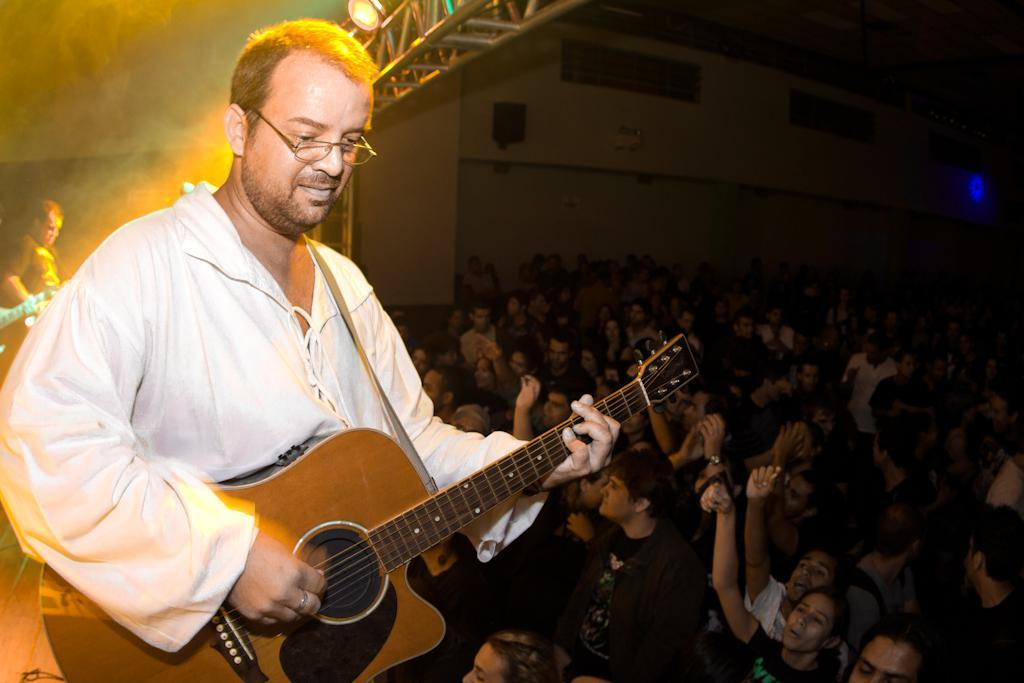What is the man in the image holding? The man is holding a guitar. What accessory is the man wearing in the image? The man is wearing glasses (specs). Can you describe the background of the image? There are people visible in the background of the image. What type of needle is the man using to exchange coughs with the audience in the image? There is no needle or coughing depicted in the image. The man is holding a guitar and wearing glasses, and there are people visible in the background. 